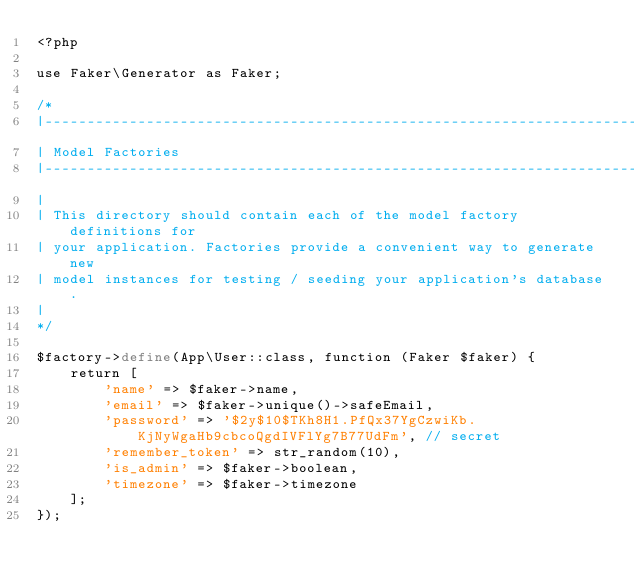<code> <loc_0><loc_0><loc_500><loc_500><_PHP_><?php

use Faker\Generator as Faker;

/*
|--------------------------------------------------------------------------
| Model Factories
|--------------------------------------------------------------------------
|
| This directory should contain each of the model factory definitions for
| your application. Factories provide a convenient way to generate new
| model instances for testing / seeding your application's database.
|
*/

$factory->define(App\User::class, function (Faker $faker) {
    return [
        'name' => $faker->name,
        'email' => $faker->unique()->safeEmail,
        'password' => '$2y$10$TKh8H1.PfQx37YgCzwiKb.KjNyWgaHb9cbcoQgdIVFlYg7B77UdFm', // secret
        'remember_token' => str_random(10),
        'is_admin' => $faker->boolean,
        'timezone' => $faker->timezone
    ];
});
</code> 